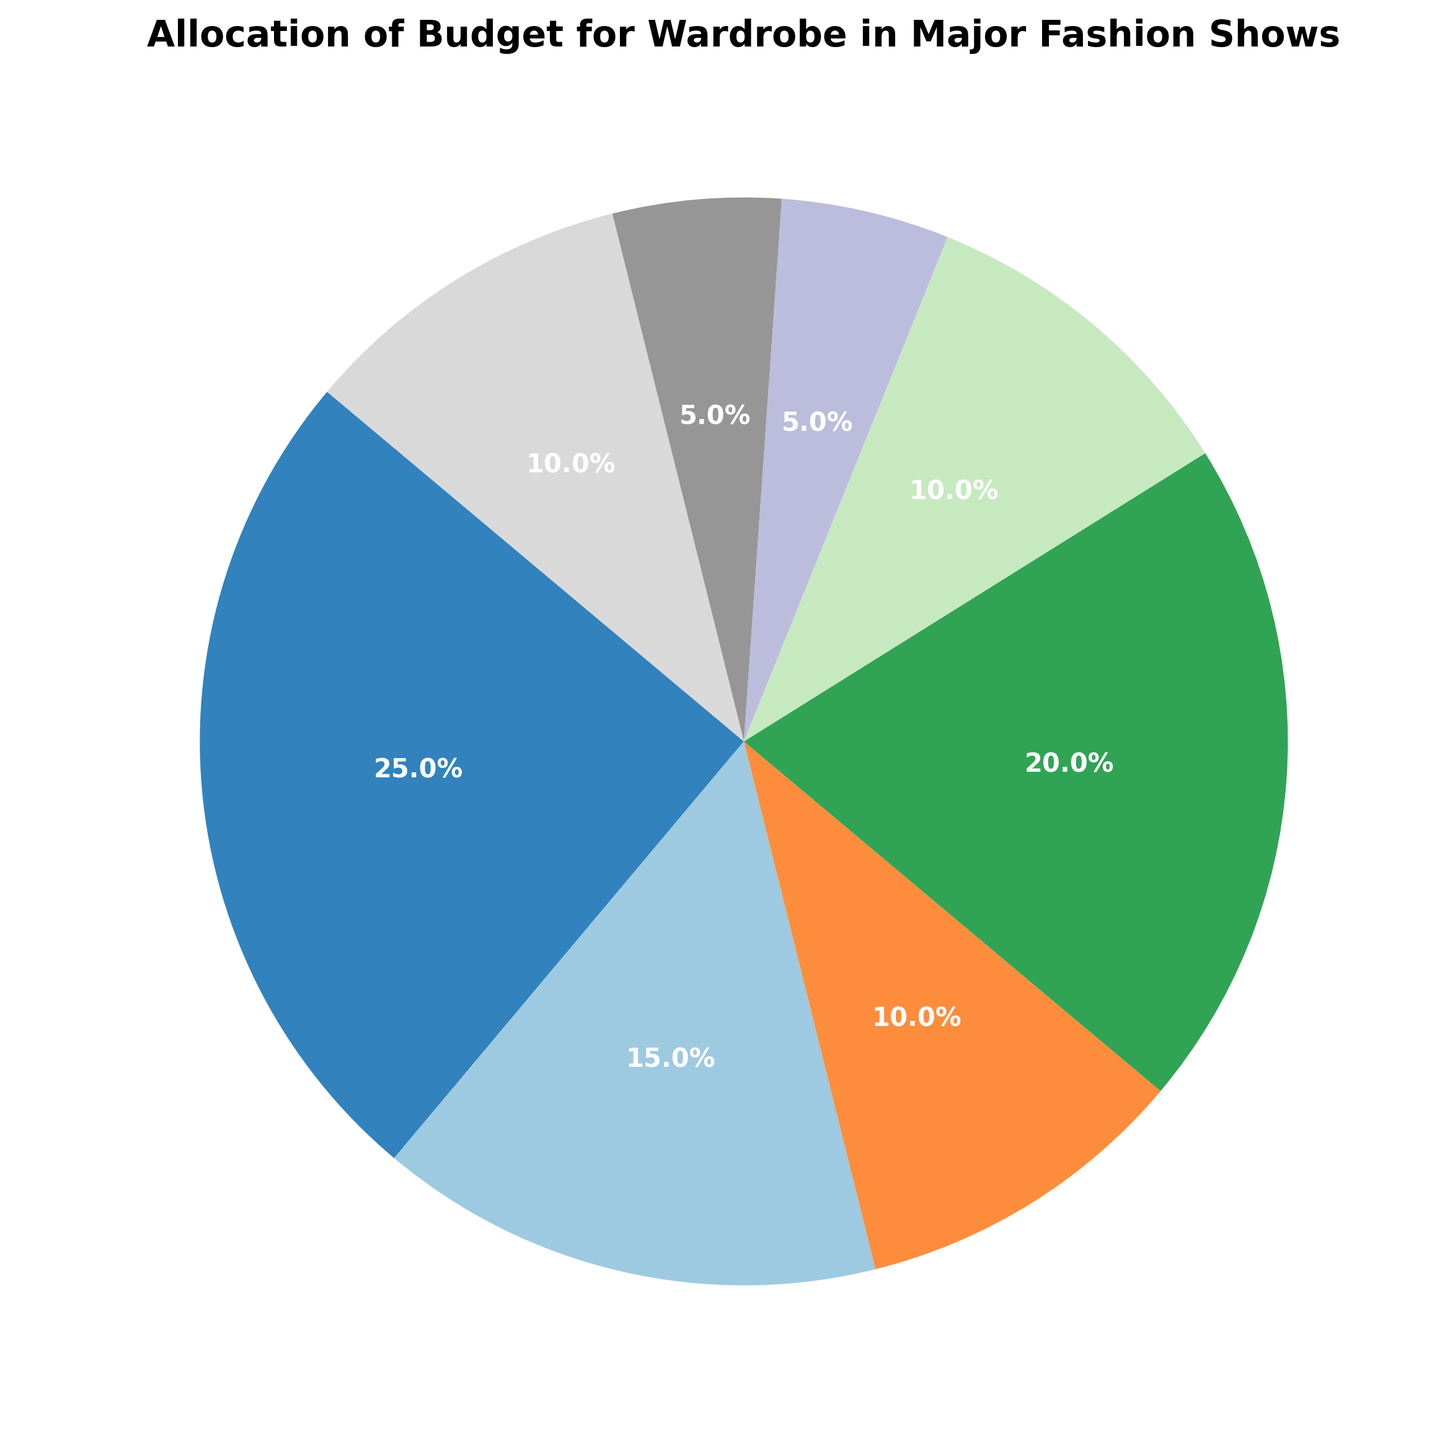Which category has the highest budget allocation? According to the pie chart, the category 'Designers' has the largest portion of the pie, which indicates the highest budget allocation.
Answer: Designers Which category has the lowest budget allocation? The category 'Venue' has the smallest portion of the pie chart, indicating the lowest budget allocation.
Answer: Venue What is the combined percentage of the budget allocated to Models, Makeup and Hair, and Accessories? The percentages for Models, Makeup and Hair, and Accessories are 20%, 10%, and 10%, respectively. Adding these gives 20% + 10% + 10% = 40%.
Answer: 40% Is the budget for Designers greater than the combined budget for Marketing and Logistics? The budget for Designers is 25%. The combined budget for Marketing and Logistics is 10% + 5% = 15%. Since 25% > 15%, the budget for Designers is indeed greater.
Answer: Yes How much more budget percentage is allocated to Fabrics compared to Venue? The budget for Fabrics is 15% and for Venue is 5%. The difference is 15% - 5% = 10%.
Answer: 10% Which categories have an equal percentage of the budget allocation? The categories 'Makeup and Hair' and 'Accessories' both have a budget allocation of 10%. Additionally, 'Venue' and 'Logistics' both have a budget of 5%.
Answer: Makeup and Hair and Accessories, Venue and Logistics How many categories have a budget allocation of 10% or more? From the pie chart, the categories with budget allocations of 10% or more are Designers (25%), Models (20%), Fabrics (15%), Accessories (10%), Makeup and Hair (10%), and Marketing (10%), totaling to 6 categories.
Answer: 6 What percentage of the budget is allocated to items directly related to the look of the show (Designers, Fabrics, Accessories, Makeup and Hair)? Summing up the percentages for Designers (25%), Fabrics (15%), Accessories (10%), and Makeup and Hair (10%) gives 25% + 15% + 10% + 10% = 60%.
Answer: 60% Is the budget for Models less than the budget combined for Fabrics and Accessories? The budget for Models is 20%. The combined budget for Fabrics and Accessories is 15% + 10% = 25%. Since 20% < 25%, the budget for Models is less.
Answer: Yes Which category has a slightly higher budget allocation compared to Makeup and Hair? Comparing the available data from the pie chart, the category 'Marketing' has a budget allocation of 10%, which is equal to 'Makeup and Hair'. However, categories like 'Fabrics' (15%) and 'Models' (20%) have higher budgets, but might not seem 'slightly' higher. To answer the question precisely, the budget of 'Accessories' is also equal to 'Makeup and Hair'.
Answer: None, as Makeup and Hair is equal to Accessories 